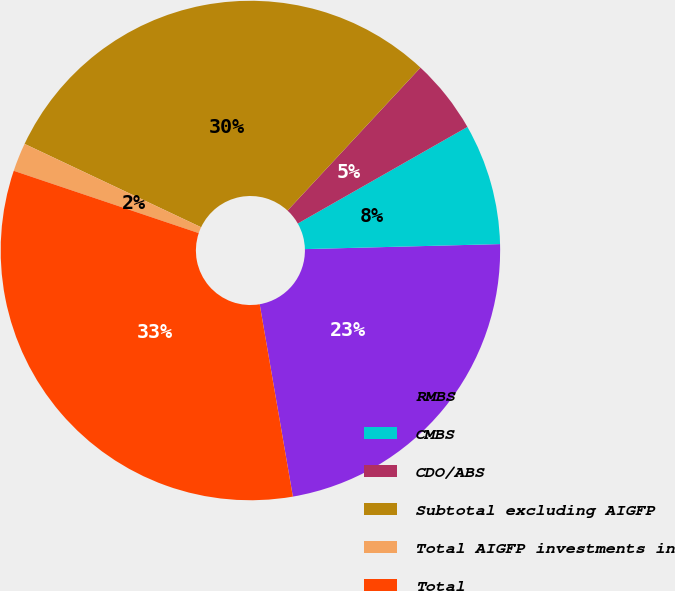Convert chart to OTSL. <chart><loc_0><loc_0><loc_500><loc_500><pie_chart><fcel>RMBS<fcel>CMBS<fcel>CDO/ABS<fcel>Subtotal excluding AIGFP<fcel>Total AIGFP investments in<fcel>Total<nl><fcel>22.69%<fcel>7.83%<fcel>4.84%<fcel>29.9%<fcel>1.85%<fcel>32.89%<nl></chart> 